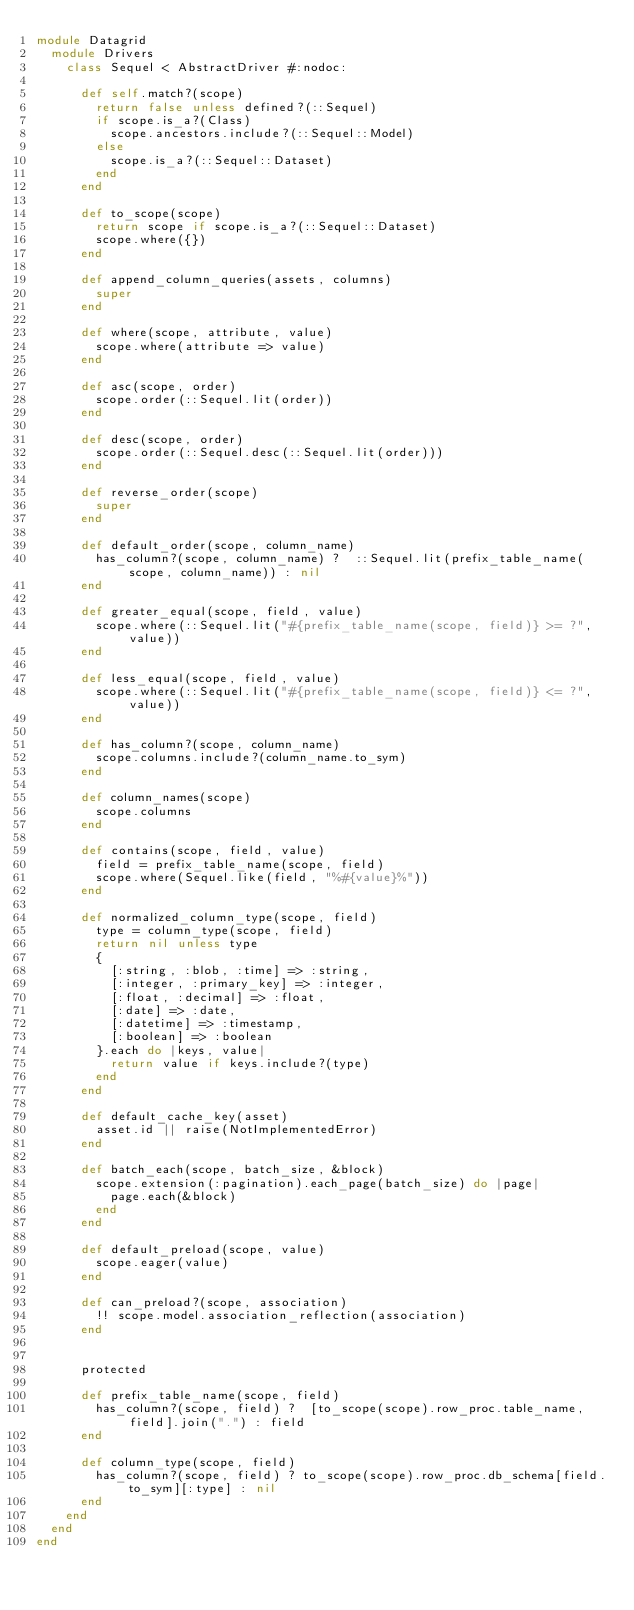Convert code to text. <code><loc_0><loc_0><loc_500><loc_500><_Ruby_>module Datagrid
  module Drivers
    class Sequel < AbstractDriver #:nodoc:

      def self.match?(scope)
        return false unless defined?(::Sequel)
        if scope.is_a?(Class)
          scope.ancestors.include?(::Sequel::Model)
        else
          scope.is_a?(::Sequel::Dataset)
        end
      end

      def to_scope(scope)
        return scope if scope.is_a?(::Sequel::Dataset)
        scope.where({})
      end

      def append_column_queries(assets, columns)
        super
      end

      def where(scope, attribute, value)
        scope.where(attribute => value)
      end

      def asc(scope, order)
        scope.order(::Sequel.lit(order))
      end

      def desc(scope, order)
        scope.order(::Sequel.desc(::Sequel.lit(order)))
      end

      def reverse_order(scope)
        super
      end

      def default_order(scope, column_name)
        has_column?(scope, column_name) ?  ::Sequel.lit(prefix_table_name(scope, column_name)) : nil
      end

      def greater_equal(scope, field, value)
        scope.where(::Sequel.lit("#{prefix_table_name(scope, field)} >= ?", value))
      end

      def less_equal(scope, field, value)
        scope.where(::Sequel.lit("#{prefix_table_name(scope, field)} <= ?", value))
      end

      def has_column?(scope, column_name)
        scope.columns.include?(column_name.to_sym)
      end

      def column_names(scope)
        scope.columns
      end

      def contains(scope, field, value)
        field = prefix_table_name(scope, field)
        scope.where(Sequel.like(field, "%#{value}%"))
      end

      def normalized_column_type(scope, field)
        type = column_type(scope, field)
        return nil unless type
        {
          [:string, :blob, :time] => :string,
          [:integer, :primary_key] => :integer,
          [:float, :decimal] => :float,
          [:date] => :date,
          [:datetime] => :timestamp,
          [:boolean] => :boolean
        }.each do |keys, value|
          return value if keys.include?(type)
        end
      end

      def default_cache_key(asset)
        asset.id || raise(NotImplementedError)
      end

      def batch_each(scope, batch_size, &block)
        scope.extension(:pagination).each_page(batch_size) do |page|
          page.each(&block)
        end
      end

      def default_preload(scope, value)
        scope.eager(value)
      end

      def can_preload?(scope, association)
        !! scope.model.association_reflection(association)
      end


      protected

      def prefix_table_name(scope, field)
        has_column?(scope, field) ?  [to_scope(scope).row_proc.table_name, field].join(".") : field
      end

      def column_type(scope, field)
        has_column?(scope, field) ? to_scope(scope).row_proc.db_schema[field.to_sym][:type] : nil
      end
    end
  end
end
</code> 